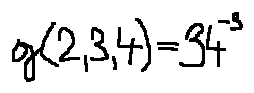<formula> <loc_0><loc_0><loc_500><loc_500>g ( 2 , 3 , 4 ) = 3 4 ^ { - 3 }</formula> 